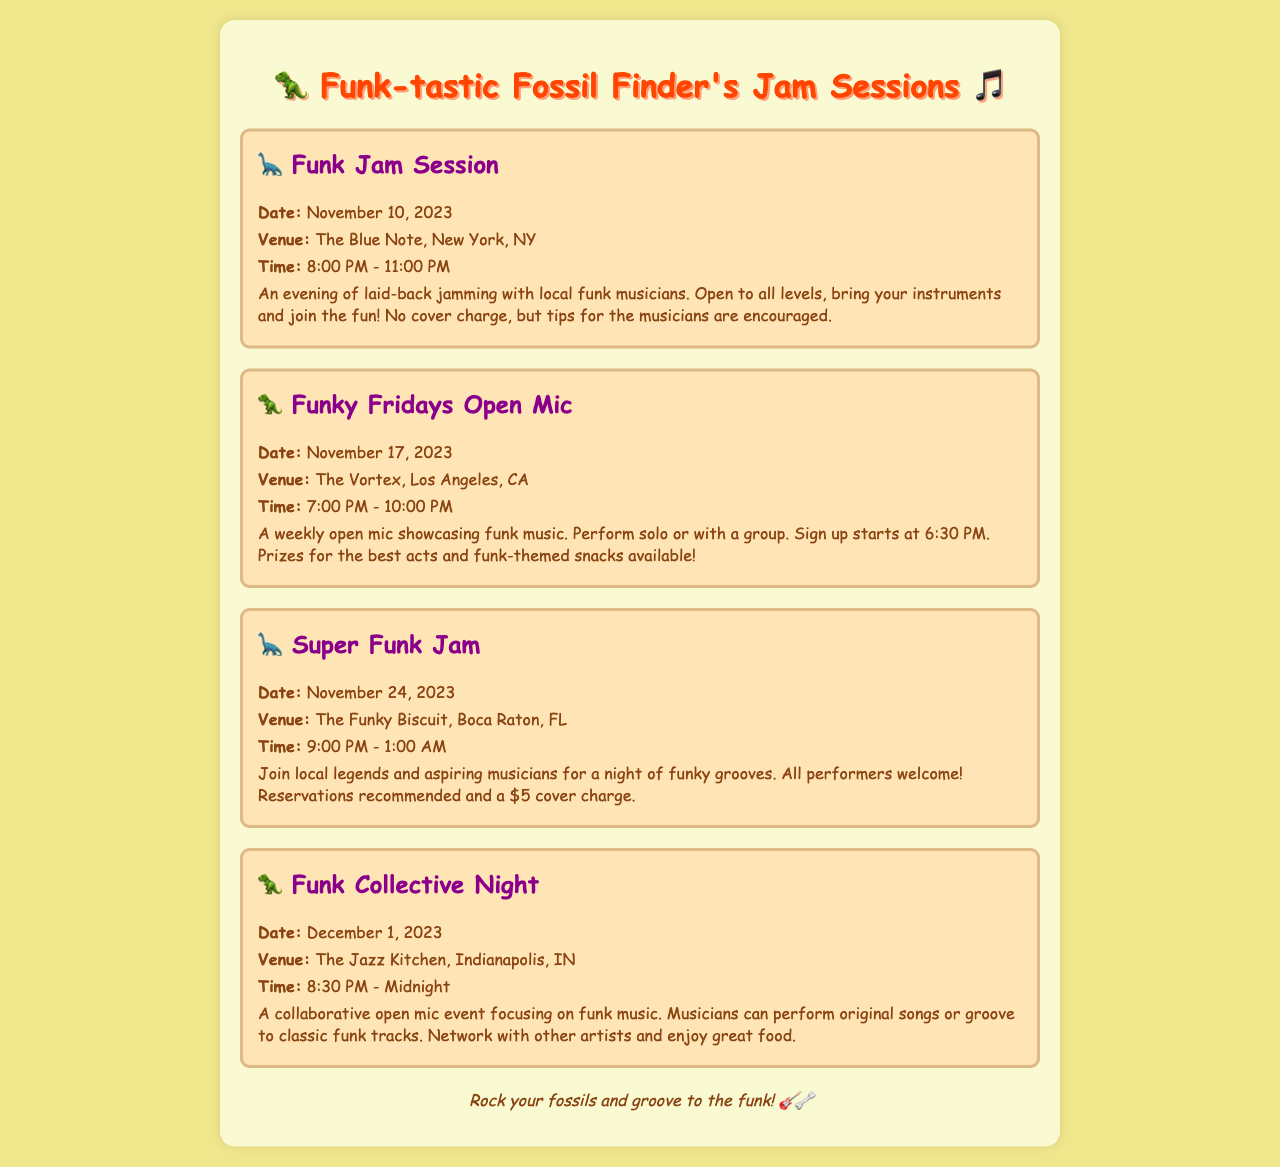What is the date of the Funk Jam Session? The Funk Jam Session is scheduled for November 10, 2023, as mentioned in the document.
Answer: November 10, 2023 Where is the Funky Fridays Open Mic held? The Funky Fridays Open Mic takes place at The Vortex in Los Angeles, CA.
Answer: The Vortex, Los Angeles, CA What time does the Super Funk Jam start? The Super Funk Jam begins at 9:00 PM, according to the schedule provided.
Answer: 9:00 PM How much is the cover charge for the Super Funk Jam? The document states that there is a $5 cover charge for the Super Funk Jam.
Answer: $5 What type of event is the Funk Collective Night? The Funk Collective Night is described as a collaborative open mic event focusing on funk music.
Answer: Collaborative open mic event When does sign up start for the Funky Fridays Open Mic? Sign up for the Funky Fridays Open Mic starts at 6:30 PM, as specified in the text.
Answer: 6:30 PM What is offered at the Funky Fridays Open Mic besides performances? The document mentions that prizes for the best acts and funk-themed snacks are available.
Answer: Prizes and snacks What is the duration of the Funk Jam Session? The Funk Jam Session lasts from 8:00 PM to 11:00 PM, making it a three-hour event.
Answer: 3 hours What is encouraged for musicians at the Funk Jam Session? The document notes that tips for the musicians are encouraged at the Funk Jam Session.
Answer: Tips for musicians 